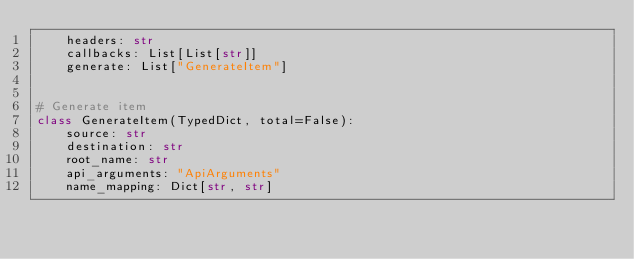<code> <loc_0><loc_0><loc_500><loc_500><_Python_>    headers: str
    callbacks: List[List[str]]
    generate: List["GenerateItem"]


# Generate item
class GenerateItem(TypedDict, total=False):
    source: str
    destination: str
    root_name: str
    api_arguments: "ApiArguments"
    name_mapping: Dict[str, str]
</code> 